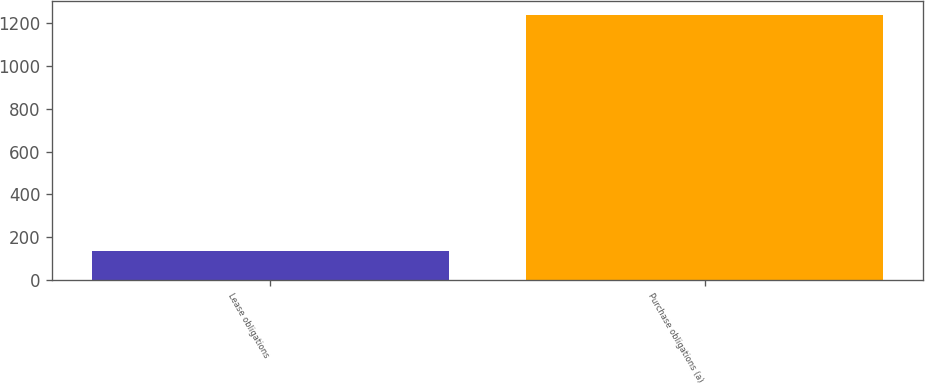Convert chart. <chart><loc_0><loc_0><loc_500><loc_500><bar_chart><fcel>Lease obligations<fcel>Purchase obligations (a)<nl><fcel>138<fcel>1238<nl></chart> 